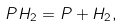Convert formula to latex. <formula><loc_0><loc_0><loc_500><loc_500>P H _ { 2 } = P + H _ { 2 } ,</formula> 